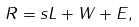<formula> <loc_0><loc_0><loc_500><loc_500>R = s L + W + E ,</formula> 